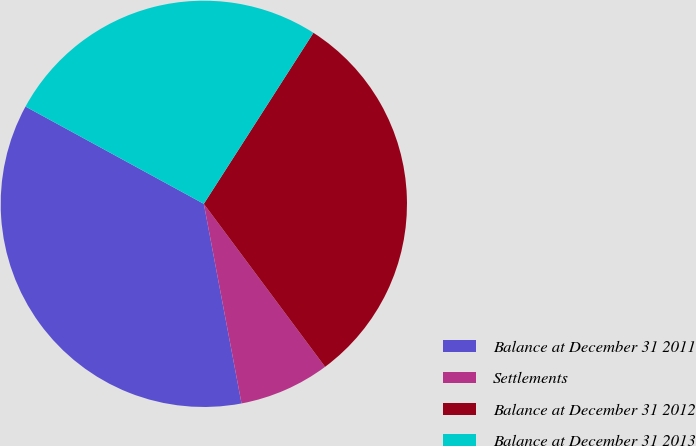Convert chart. <chart><loc_0><loc_0><loc_500><loc_500><pie_chart><fcel>Balance at December 31 2011<fcel>Settlements<fcel>Balance at December 31 2012<fcel>Balance at December 31 2013<nl><fcel>35.92%<fcel>7.21%<fcel>30.75%<fcel>26.12%<nl></chart> 